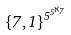Convert formula to latex. <formula><loc_0><loc_0><loc_500><loc_500>\{ 7 , 1 \} ^ { 5 ^ { 5 ^ { \aleph _ { 7 } } } }</formula> 